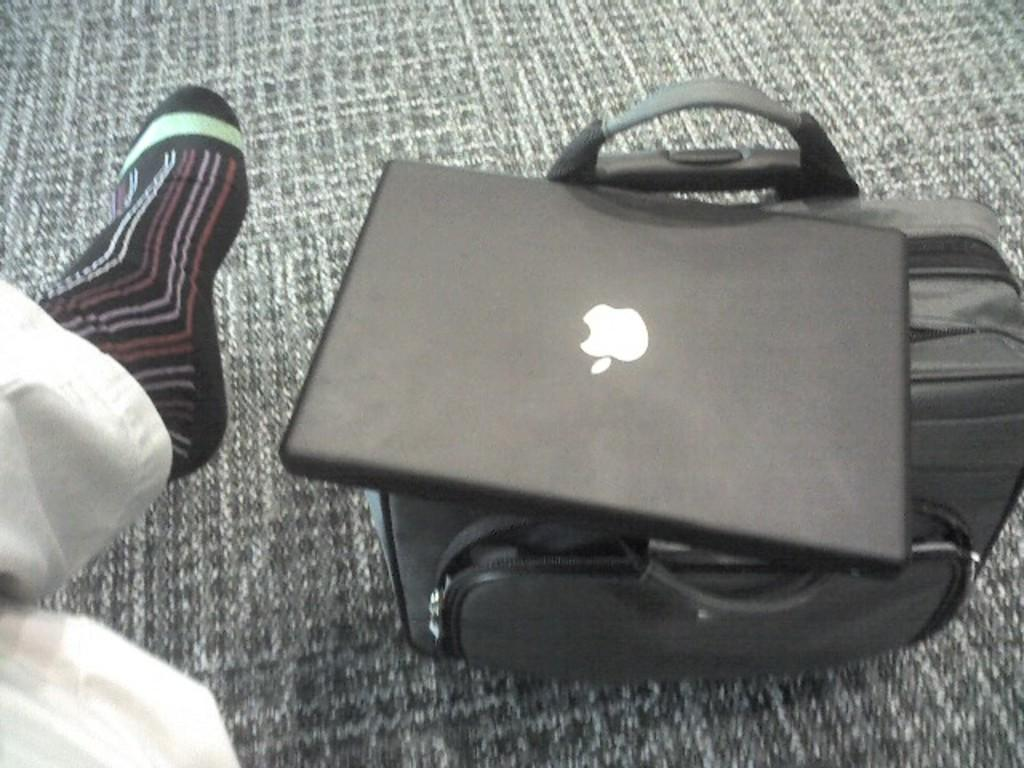What electronic device is visible in the image? There is a laptop in the image. What object is present that might be used for carrying items? There is a bag in the image. Can you describe the person in the image? The person is sitting in the image and is wearing socks. What type of floor covering is visible in the image? There is a floor mat in the image. How many hens are sitting on the nest in the image? There are no hens or nests present in the image. What is the cent value of the coin on the laptop? There is no coin visible on the laptop in the image. 